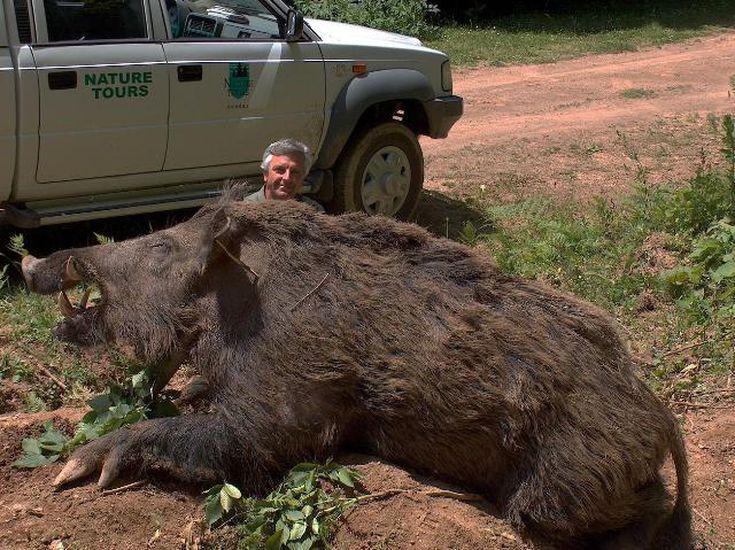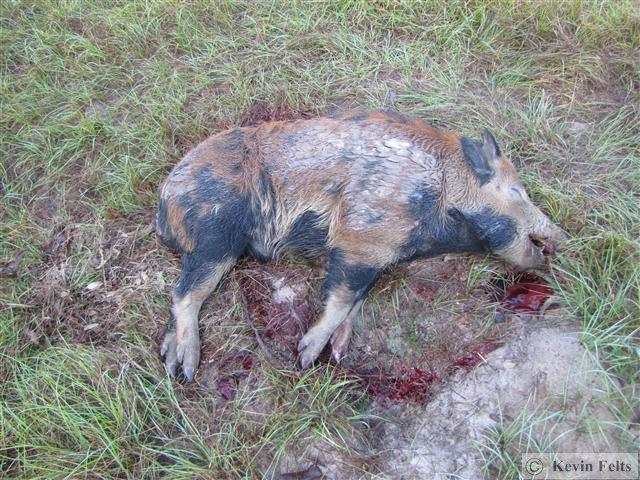The first image is the image on the left, the second image is the image on the right. Evaluate the accuracy of this statement regarding the images: "An image shows a person posed behind a dead boar.". Is it true? Answer yes or no. Yes. The first image is the image on the left, the second image is the image on the right. Considering the images on both sides, is "In one of the images there is a man posing behind a large boar." valid? Answer yes or no. Yes. 